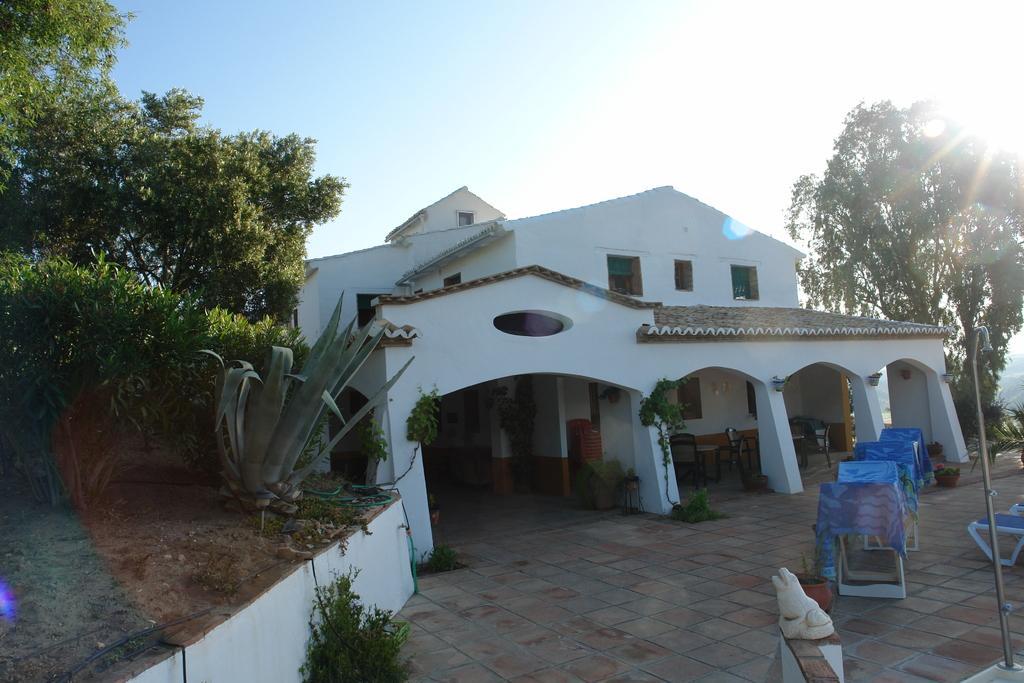Could you give a brief overview of what you see in this image? In the foreground I can see grass, plants, trees, building, windows, light pole, table, wall paintings, clothes, chairs and creepers. In the background I can see mountains and the sky. This image is taken may be during a sunny day. 